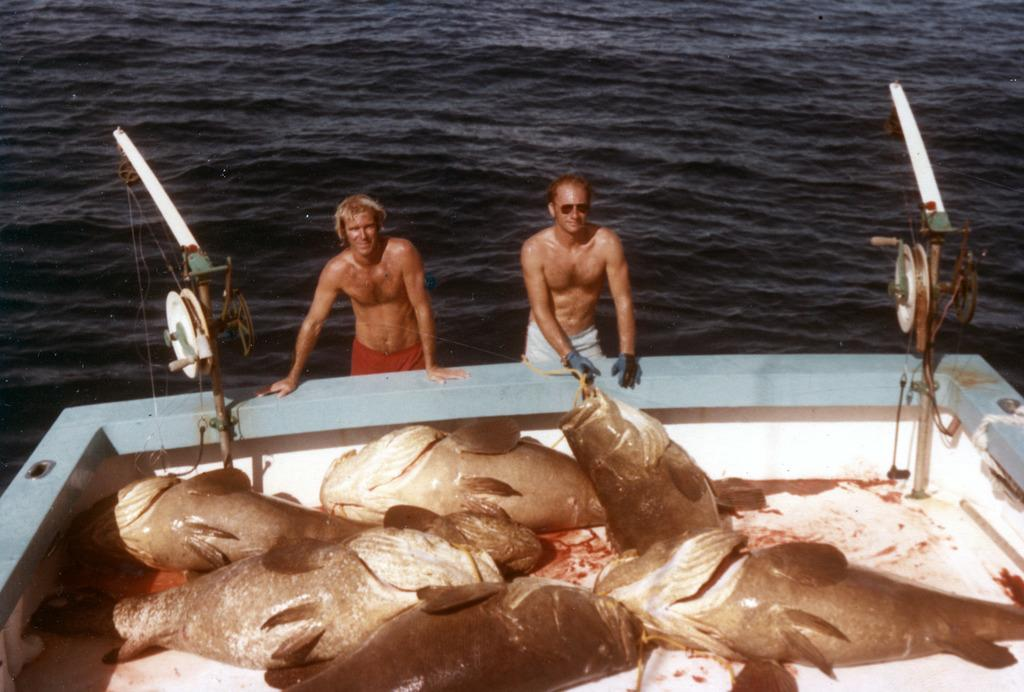How many people are in the image? There are two men standing in the image. What is in front of the men? There is a boat in front of the men. What can be seen in the water near the boat? There are fishes visible in the image. What equipment is being used by the men? There are two fishing rods in the image. What type of poison is being used by the men in the image? There is no mention of poison in the image; the men are using fishing rods to catch fish. Can you describe the floor in the image? There is no floor visible in the image, as it appears to be taken on a boat or near the water's edge. 